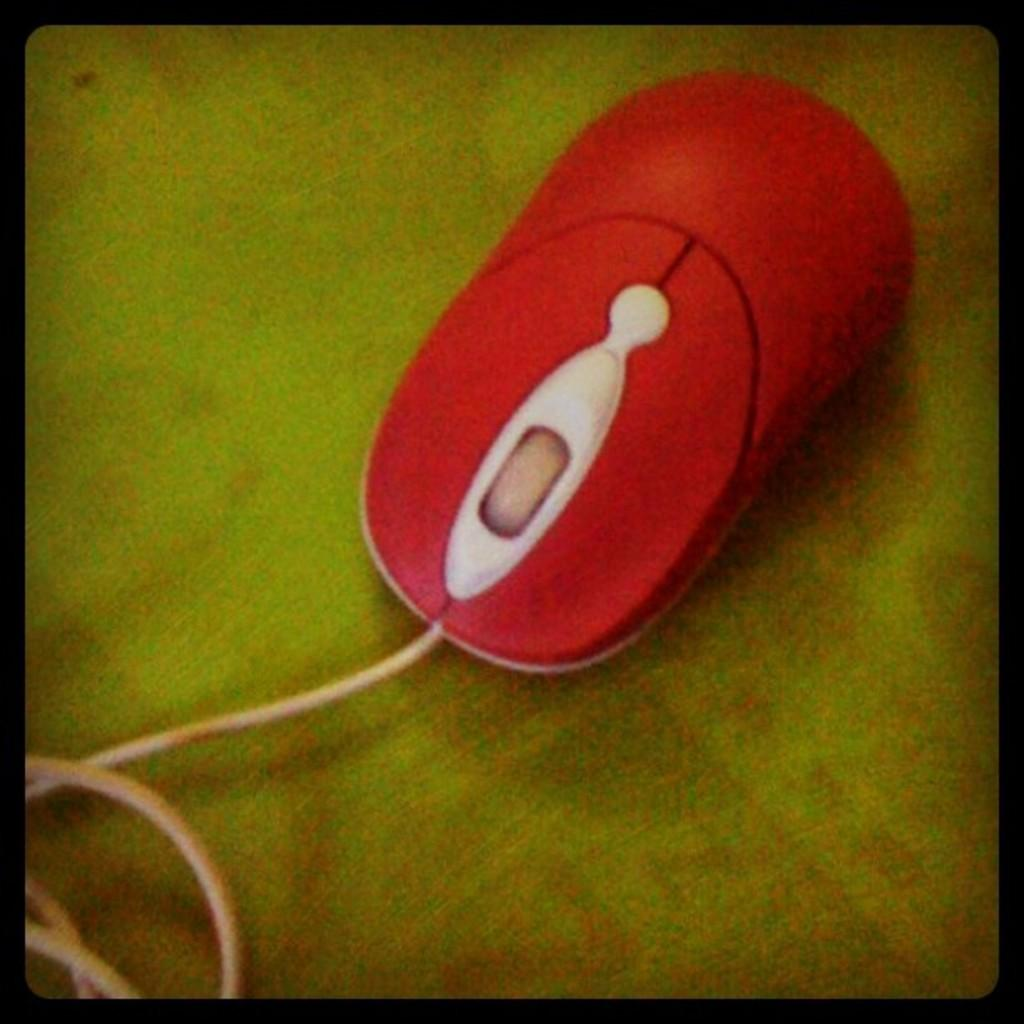What type of furniture is present in the image? There is a table in the image. What is located on the table in the image? There is a mouse and a wire on the table. How does the mouse feel shame in the image? There is no indication in the image that the mouse is feeling shame. Can you tell me how far the mouse can stretch in the image? There is no indication in the image of the mouse stretching or its ability to stretch. 